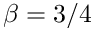<formula> <loc_0><loc_0><loc_500><loc_500>\beta = 3 / 4</formula> 